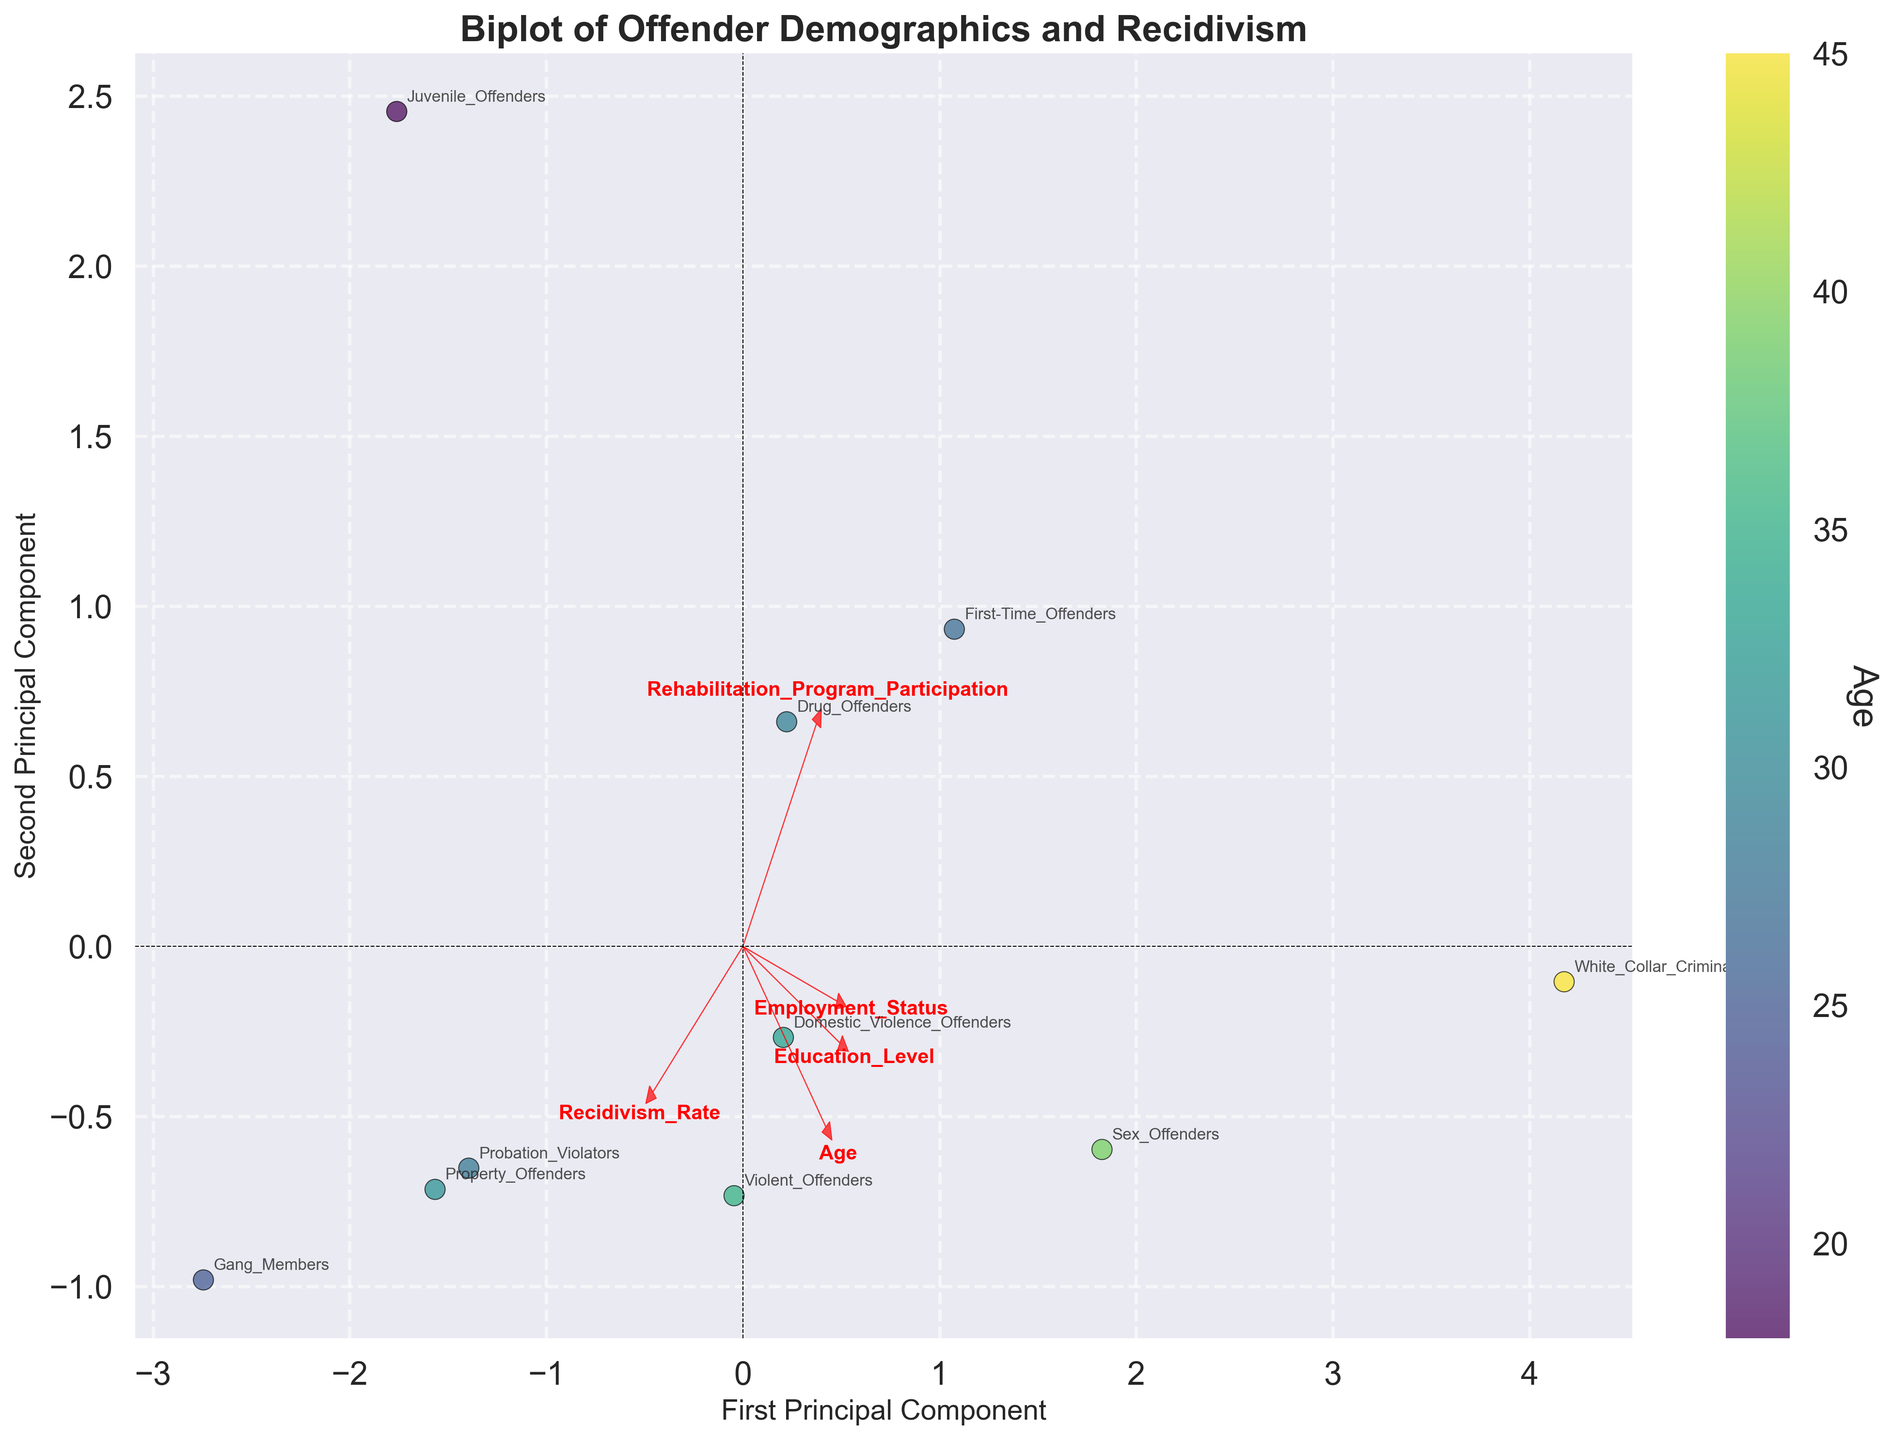What is the title of the plot? The title of the plot is prominently displayed at the top. It reads "Biplot of Offender Demographics and Recidivism"
Answer: Biplot of Offender Demographics and Recidivism Which offender group shows the highest recidivism rate? The plot has data points labeled for different offender groups. By finding the point farthest along the recidivism rate axis, Gang Members show the highest recidivism rate.
Answer: Gang Members Which demographic variable is represented by the color of the points in the scatter plot? There is a color bar on the right side of the plot that labels the variable represented by the color of the points. It is labeled "Age."
Answer: Age How many principal components are represented in the biplot? The axis labels indicate "First Principal Component" and "Second Principal Component," meaning the plot shows two principal components derived from PCA.
Answer: Two Which group is closest to the arrow representing 'Education Level'? The arrow for 'Education Level' points in a specific direction. The group closest to this arrow, based on the plot, is White Collar Criminals.
Answer: White Collar Criminals Which group has a higher recidivism rate: Drug Offenders or Domestic Violence Offenders? Locate the points labeled 'Drug Offenders' and 'Domestic Violence Offenders' on the plot and compare their positions relative to the recidivism rate axis. Drug Offenders have a lower recidivism rate than Domestic Violence Offenders.
Answer: Domestic Violence Offenders Identify the two groups with the most considerable difference in rehabilitation program participation. Examination of the scatter plot shows that Gang Members (lowest) and White Collar Criminals (highest) have the largest gap in rehabilitation program participation.
Answer: Gang Members and White Collar Criminals What feature has the smallest arrow pointing to in the biplot? By comparing the lengths of all the arrows, we see that 'Employment Status' has the smallest arrow, indicating it has the least influence in this PCA visualization.
Answer: Employment Status Which offender group shows the highest level of rehabilitation program participation? Look for the highest point on the axis representing rehabilitation program participation. White Collar Criminals show the highest level of participation.
Answer: White Collar Criminals 